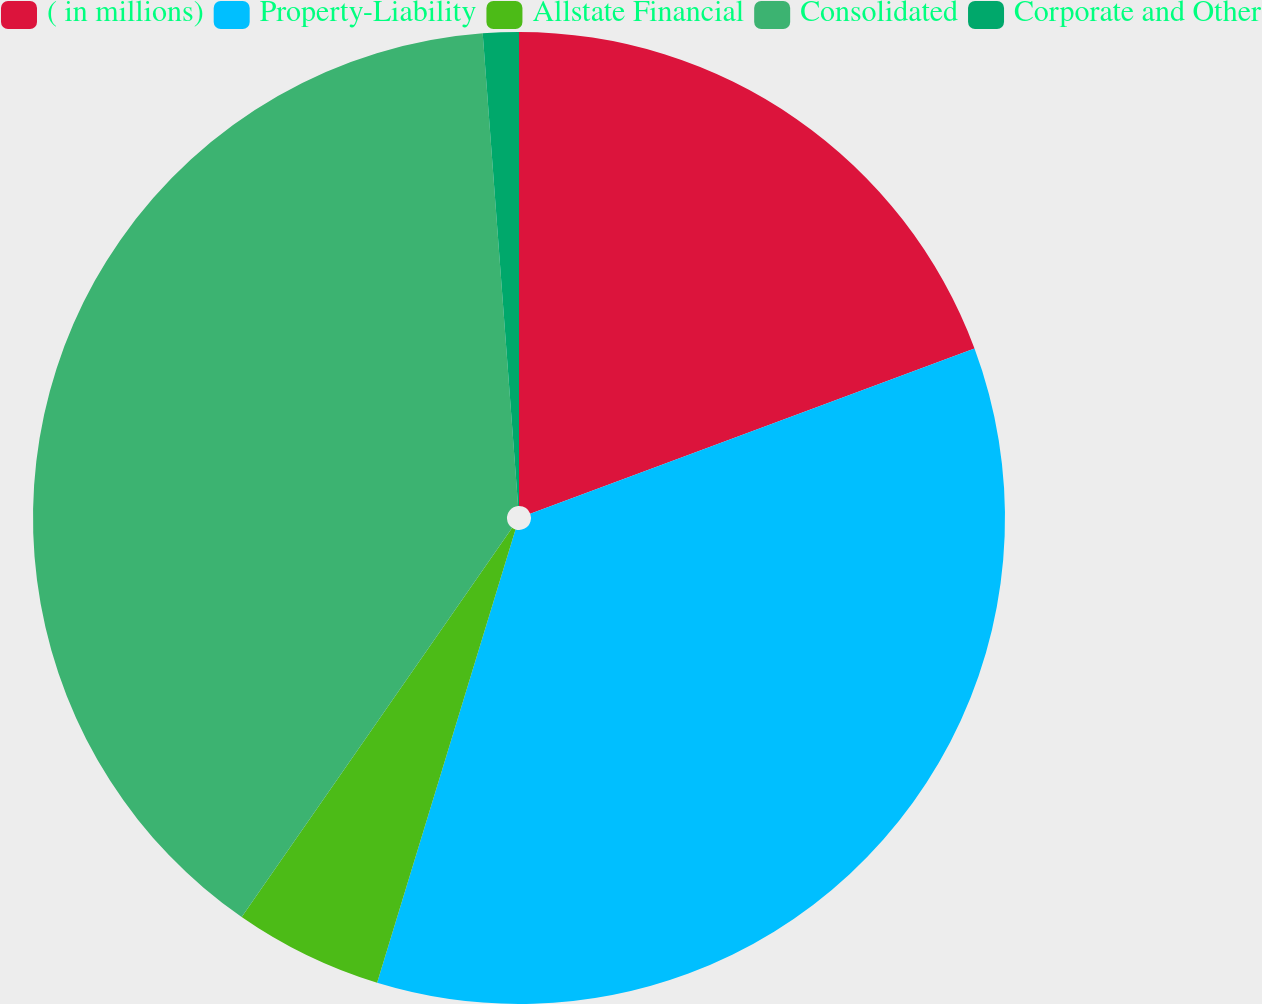<chart> <loc_0><loc_0><loc_500><loc_500><pie_chart><fcel>( in millions)<fcel>Property-Liability<fcel>Allstate Financial<fcel>Consolidated<fcel>Corporate and Other<nl><fcel>19.33%<fcel>35.38%<fcel>4.95%<fcel>39.14%<fcel>1.19%<nl></chart> 